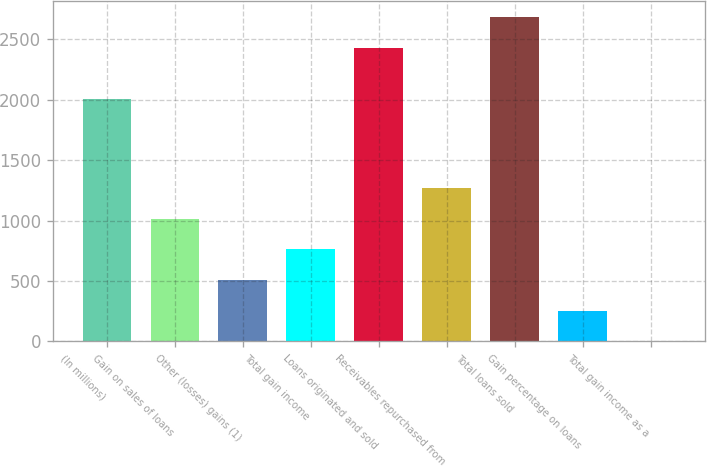Convert chart to OTSL. <chart><loc_0><loc_0><loc_500><loc_500><bar_chart><fcel>(In millions)<fcel>Gain on sales of loans<fcel>Other (losses) gains (1)<fcel>Total gain income<fcel>Loans originated and sold<fcel>Receivables repurchased from<fcel>Total loans sold<fcel>Gain percentage on loans<fcel>Total gain income as a<nl><fcel>2008<fcel>1014.9<fcel>508.4<fcel>761.65<fcel>2430.8<fcel>1268.15<fcel>2684.05<fcel>255.15<fcel>1.9<nl></chart> 